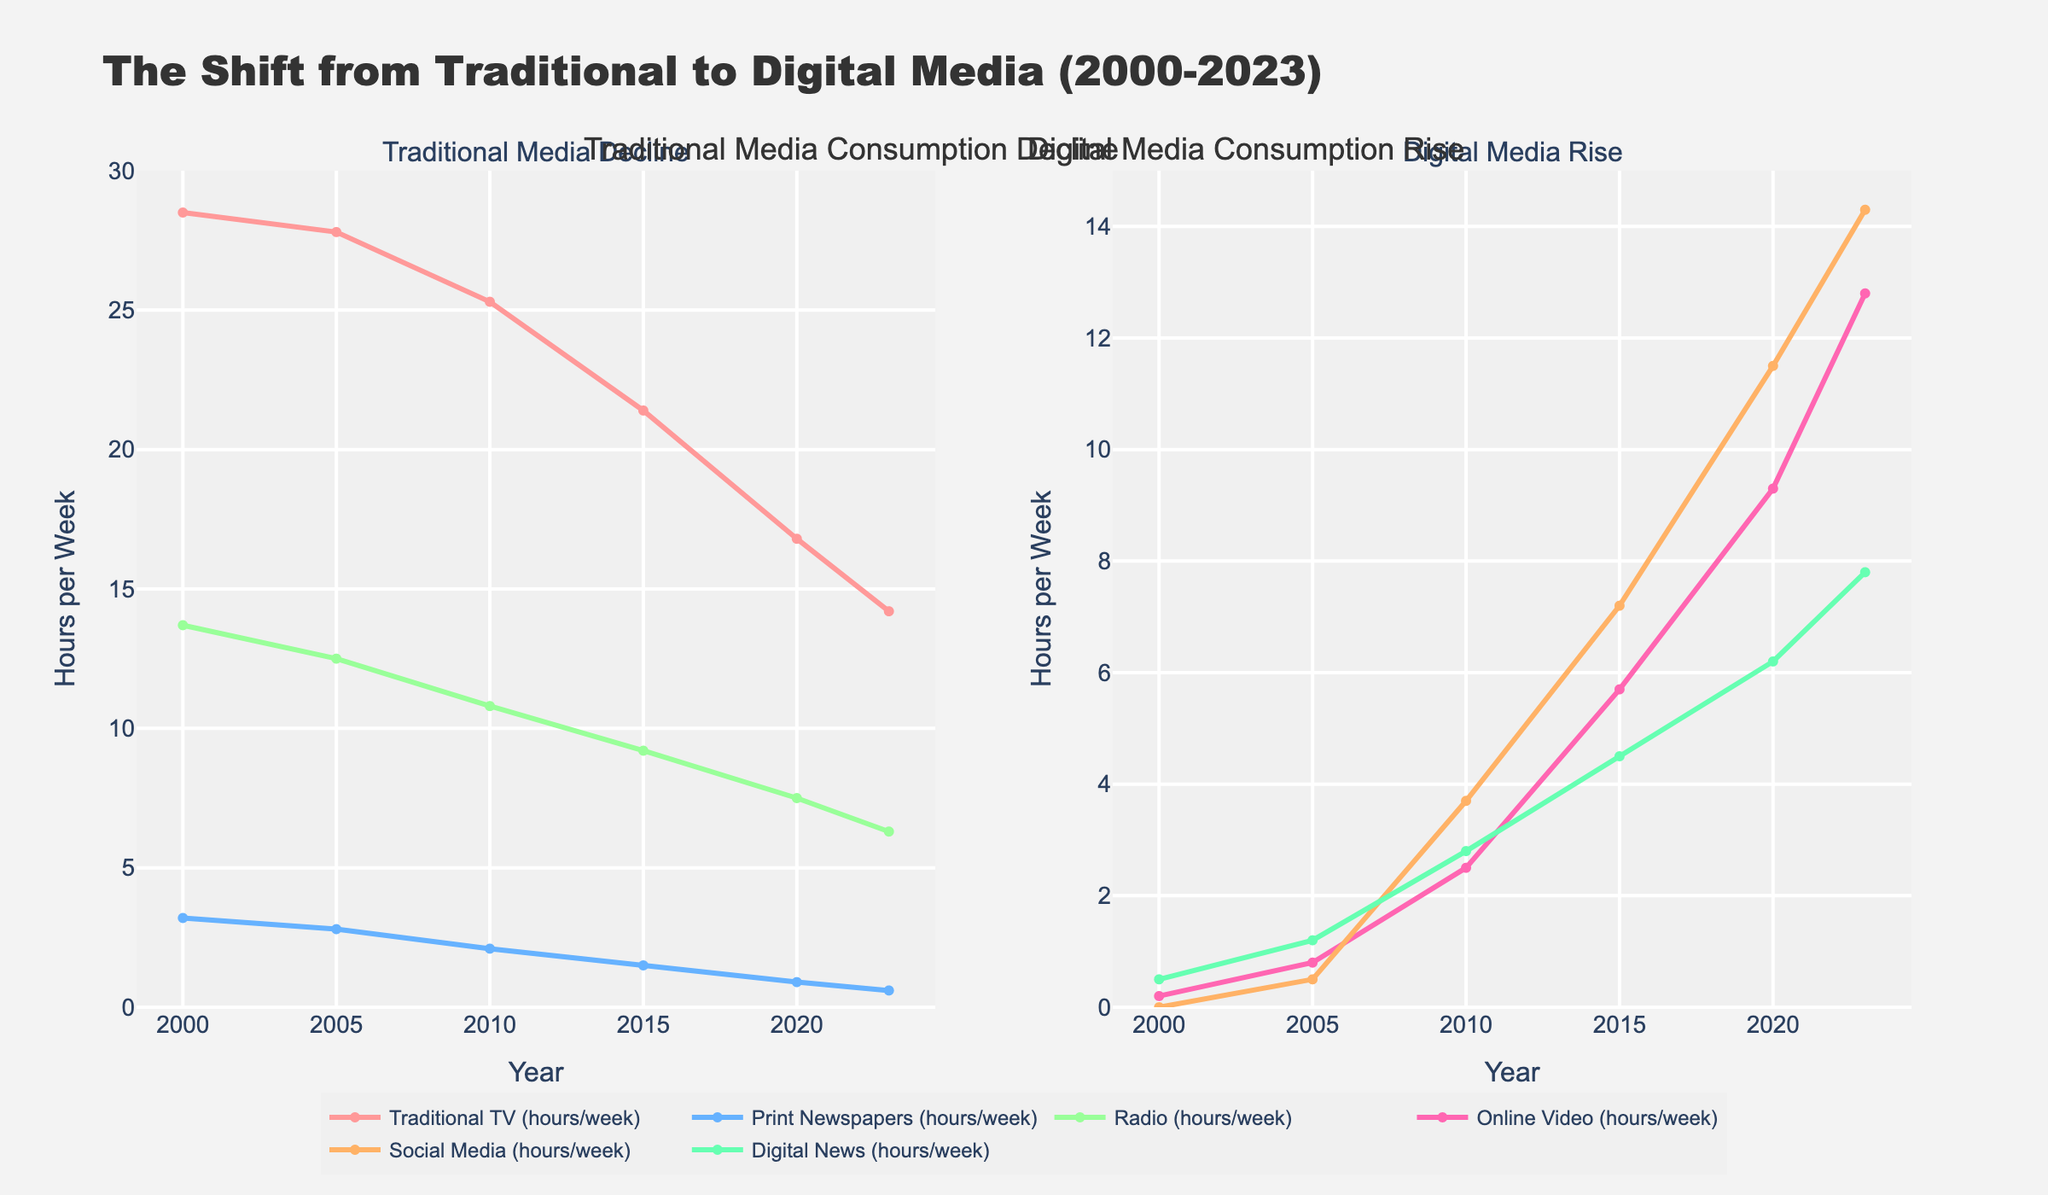How has traditional TV consumption changed from 2000 to 2023? To determine the change in traditional TV consumption, compare the values for 2000 and 2023. In 2000, traditional TV consumption was 28.5 hours per week and in 2023, it was 14.2 hours per week. Thus, there has been a decrease of 28.5 - 14.2 = 14.3 hours per week.
Answer: 14.3 hours per week Which type of digital media has seen the greatest increase in consumption from 2000 to 2023? To find the digital media with the greatest increase, look at the increase in hours per week for Online Video, Social Media, and Digital News between 2000 and 2023. Online Video increased from 0.2 to 12.8 hours, Social Media from 0 to 14.3 hours, and Digital News from 0.5 to 7.8 hours. Social Media has the greatest increase.
Answer: Social Media In which year did Print Newspapers have the greatest decline in consumption relative to the previous year? Find the differences in consumption hours between consecutive years for Print Newspapers. The greatest decline is between 2005 (2.8) and 2010 (2.1), which is a decline of 0.7 hours.
Answer: 2005 to 2010 What is the combined total of hours per week spent on Radio and Digital News in 2023? Add the hours per week for Radio and Digital News in 2023. Radio = 6.3 hours, Digital News = 7.8 hours. Thus, 6.3 + 7.8 = 14.1 hours per week.
Answer: 14.1 hours per week Compare the hours per week spent on Social Media and Radio in 2020. Which one was higher and by how much? Look at the values for 2020: Social Media = 11.5 hours, Radio = 7.5 hours. Social Media was higher by 11.5 - 7.5 = 4 hours.
Answer: Social Media by 4 hours What is the trend observed for Online Video consumption from 2000 to 2023? Observe the values for Online Video from 2000 to 2023: 0.2, 0.8, 2.5, 5.7, 9.3, 12.8. There is a consistent increase over time.
Answer: Increasing trend Which traditional media source shows the smallest decline in consumption from 2000 to 2023? Compare the declines for Traditional TV, Print Newspapers, and Radio from 2000 to 2023. Traditional TV went from 28.5 to 14.2 (14.3 decline), Print Newspapers from 3.2 to 0.6 (2.6 decline), and Radio from 13.7 to 6.3 (7.4 decline). Print Newspapers have the smallest decline of 2.6.
Answer: Print Newspapers How did Social Media consumption change between 2015 and 2020? Look at the values for Social Media in 2015 (7.2 hours) and 2020 (11.5 hours). The change is 11.5 - 7.2 = 4.3 hours increase.
Answer: Increased by 4.3 hours Calculate the average hours per week spent on Digital News from 2000 to 2023. To calculate the average, sum the Digital News values (0.5 + 1.2 + 2.8 + 4.5 + 6.2 + 7.8) and divide by the number of years (6). The total is 23, and the average is 23/6 ≈ 3.83 hours per week.
Answer: 3.83 hours per week 